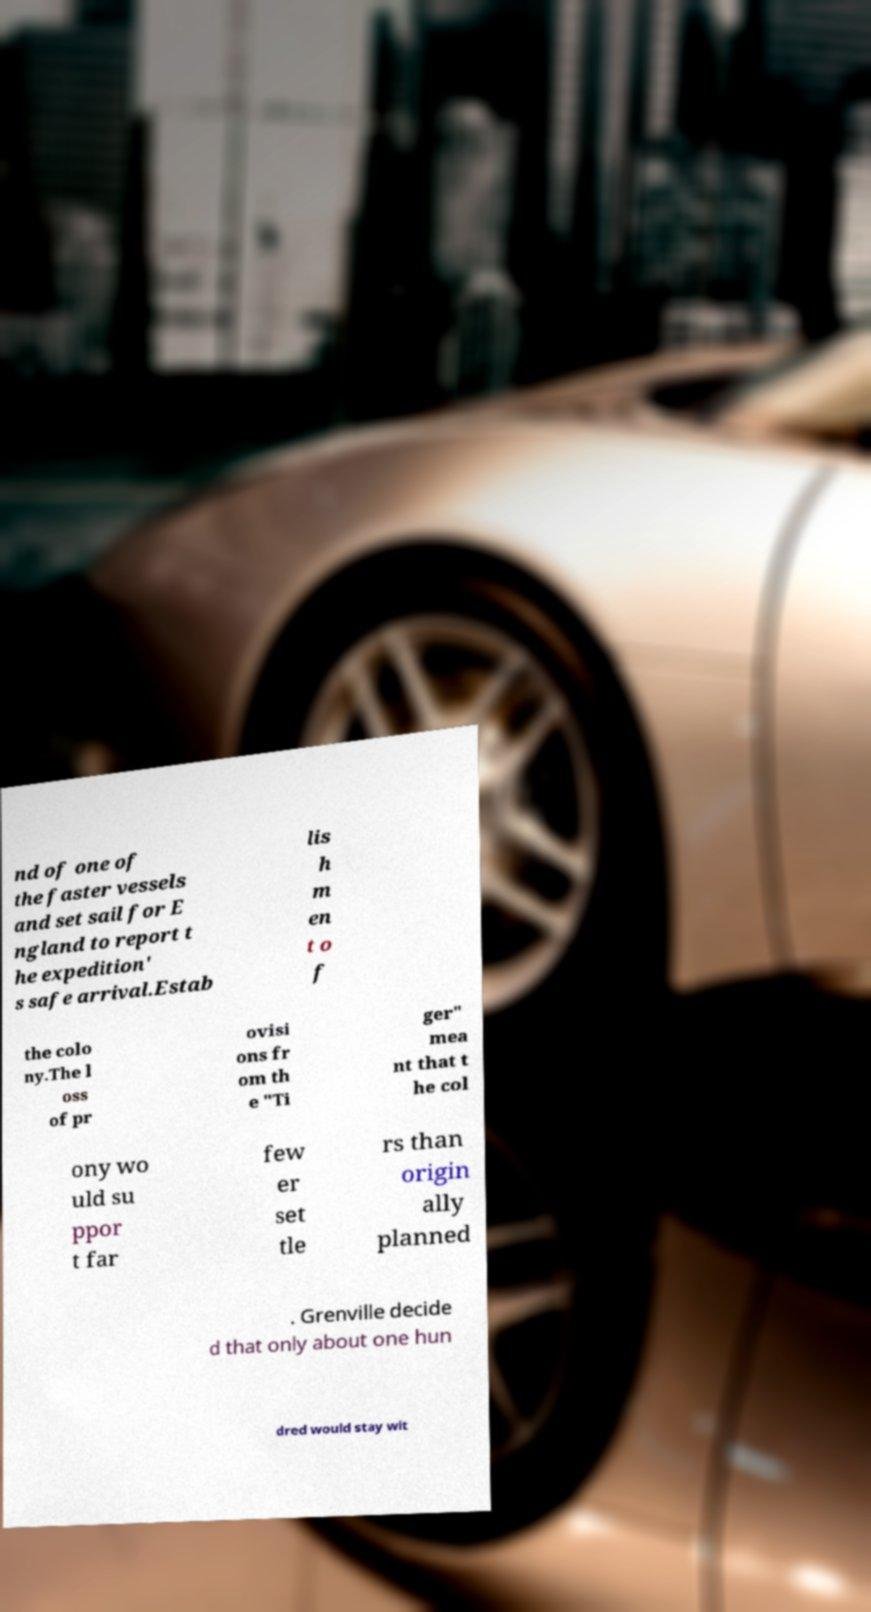Can you read and provide the text displayed in the image?This photo seems to have some interesting text. Can you extract and type it out for me? nd of one of the faster vessels and set sail for E ngland to report t he expedition' s safe arrival.Estab lis h m en t o f the colo ny.The l oss of pr ovisi ons fr om th e "Ti ger" mea nt that t he col ony wo uld su ppor t far few er set tle rs than origin ally planned . Grenville decide d that only about one hun dred would stay wit 